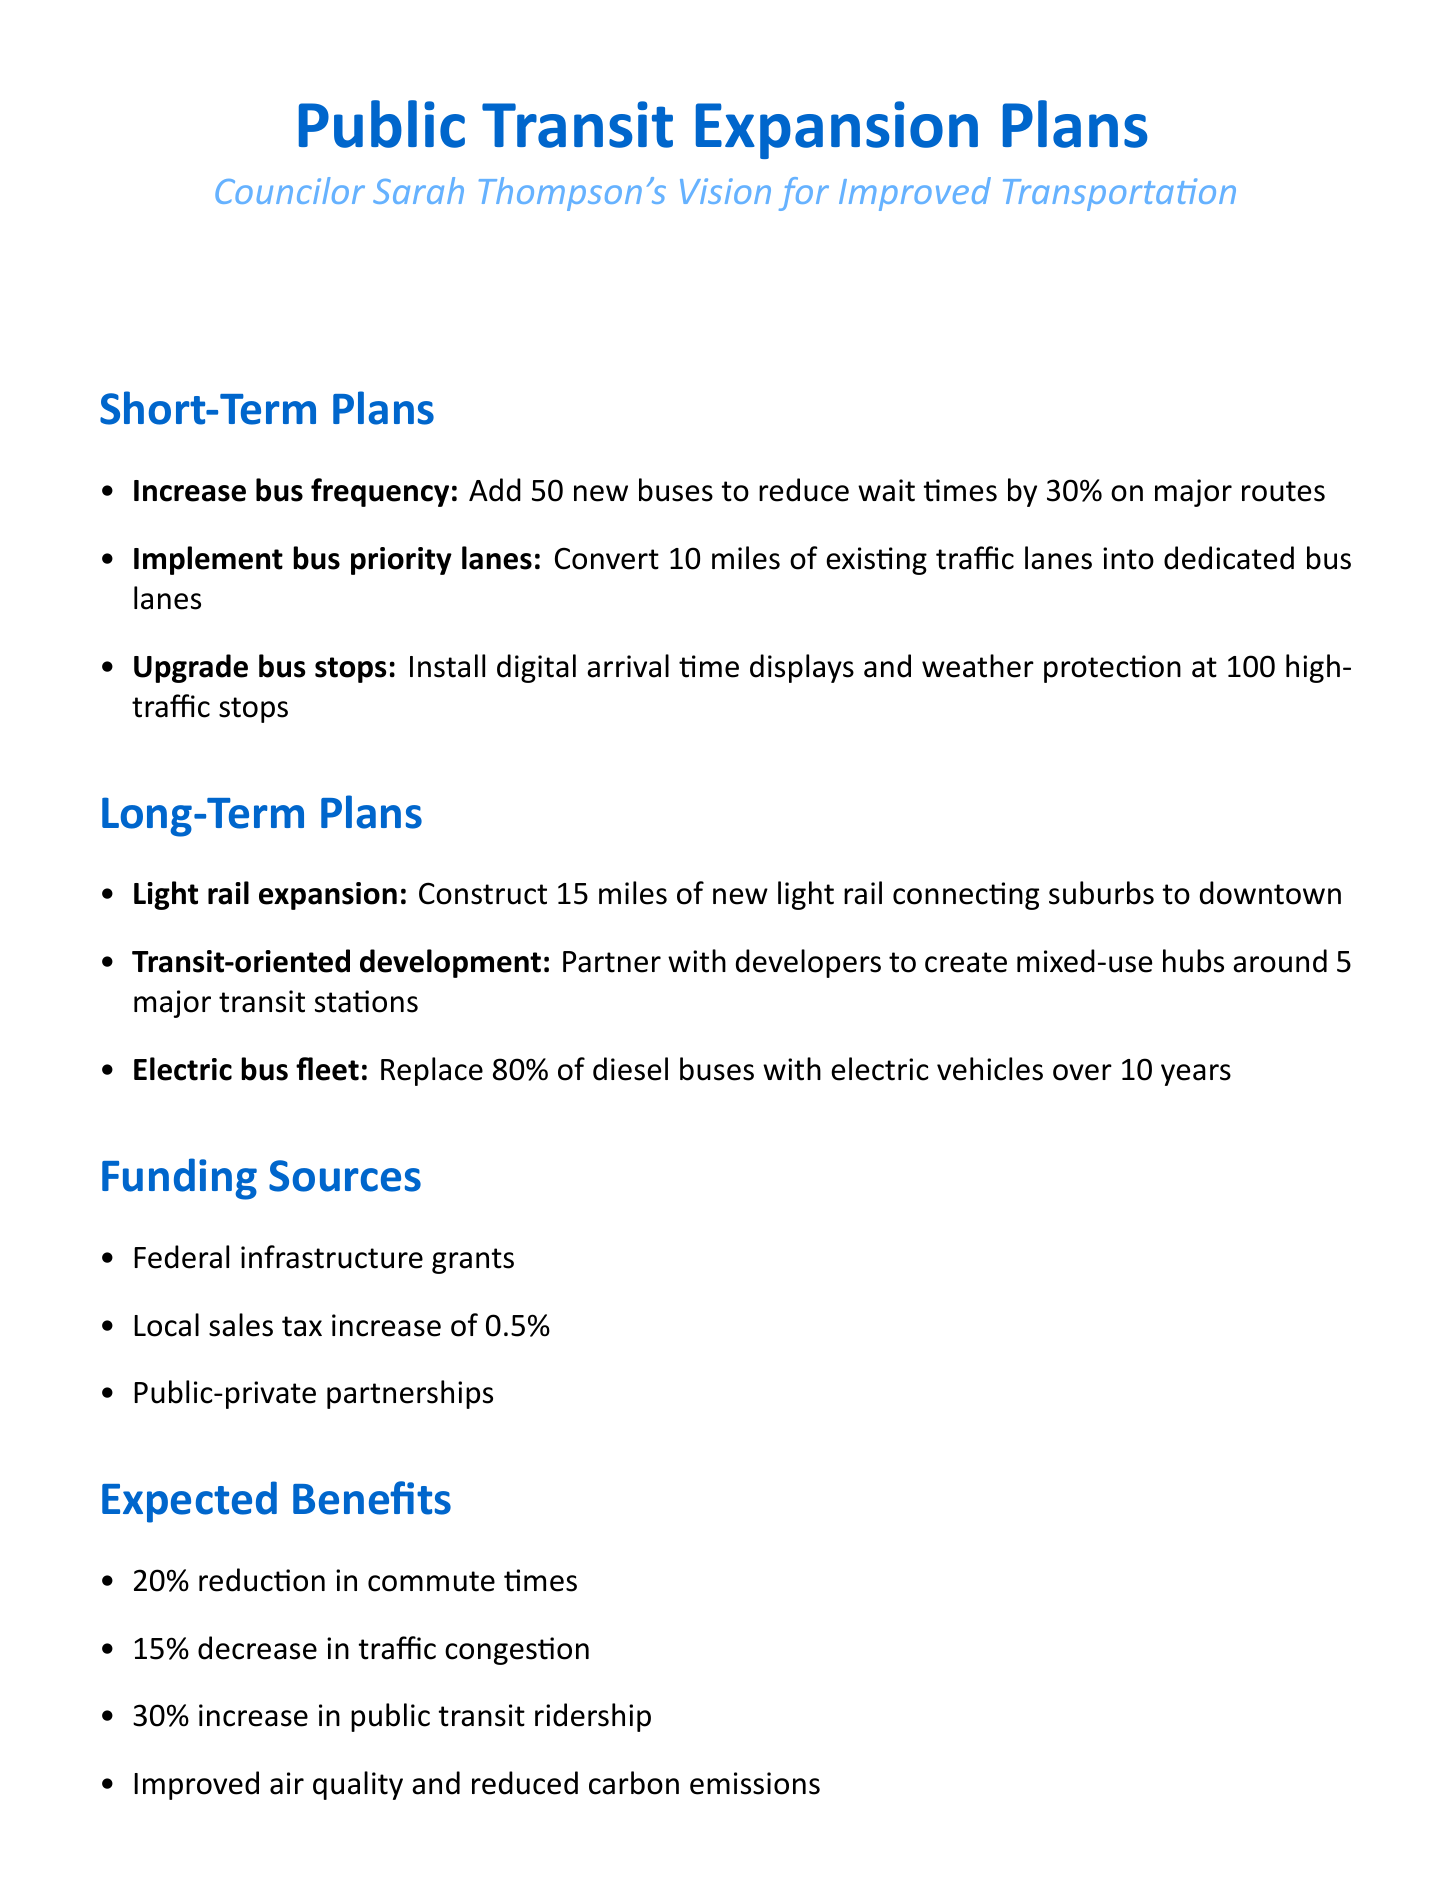What is the councilor's name? The document specifies the councilor's name as part of the title.
Answer: Sarah Thompson How many new buses will be added in the short-term plans? The document outlines the specific number of new buses planned to increase frequency.
Answer: 50 What is the target reduction in wait times for buses? It is mentioned in the short-term plans that the goal is to reduce wait times.
Answer: 30% How many miles of light rail are planned for expansion? The long-term plans specify the length of new light rail construction.
Answer: 15 miles What percentage of diesel buses will be replaced with electric vehicles? The document states the target percentage for replacing diesel buses in the long term.
Answer: 80% What is one of the expected benefits of the transit expansion? The document lists expected benefits of the public transit expansion initiatives.
Answer: 20% reduction in commute times What challenges does the councilor anticipate during the transit expansion? The document identifies issues that may arise during the implementation of the plans.
Answer: Securing consistent funding What type of funding source includes a sales tax increase? The document lists sources of funding for the proposed plans.
Answer: Local sales tax increase of 0.5% How many transit stations will have mixed-use hubs developed? The long-term plans mention the number of major transit stations for development.
Answer: 5 major transit stations 